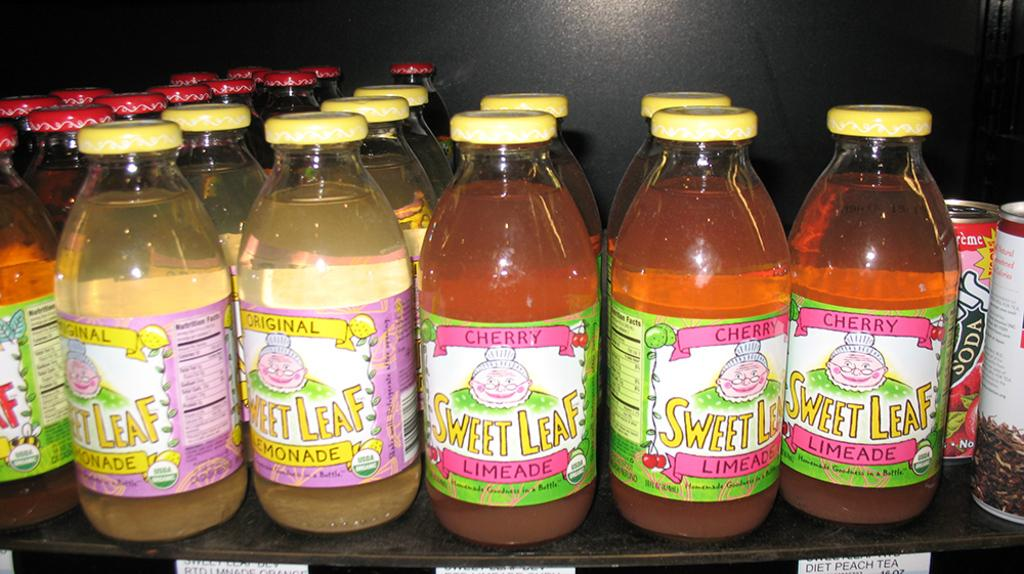What type of containers can be seen in the image? There are bottles and cans in the image. How many cans are present in the image? There are 2 cans in the image. What type of advertisement can be seen on the bottles in the image? There is no advertisement present on the bottles in the image. What type of marble is used to decorate the cans in the image? There is no marble present on the cans in the image. 